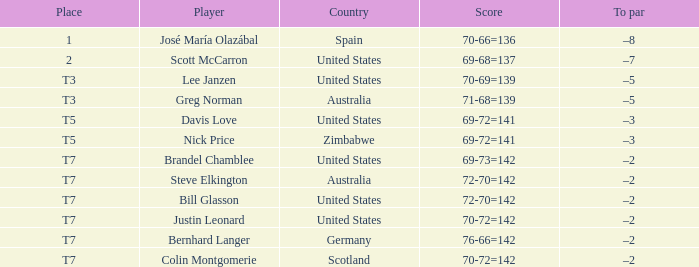WHich Place has a To par of –2, and a Player of bernhard langer? T7. 